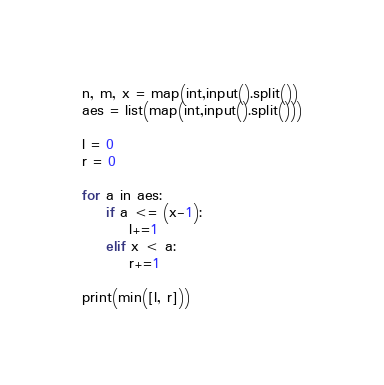Convert code to text. <code><loc_0><loc_0><loc_500><loc_500><_Python_>n, m, x = map(int,input().split())
aes = list(map(int,input().split()))

l = 0
r = 0

for a in aes:
    if a <= (x-1):
        l+=1
    elif x < a:
        r+=1

print(min([l, r]))
</code> 